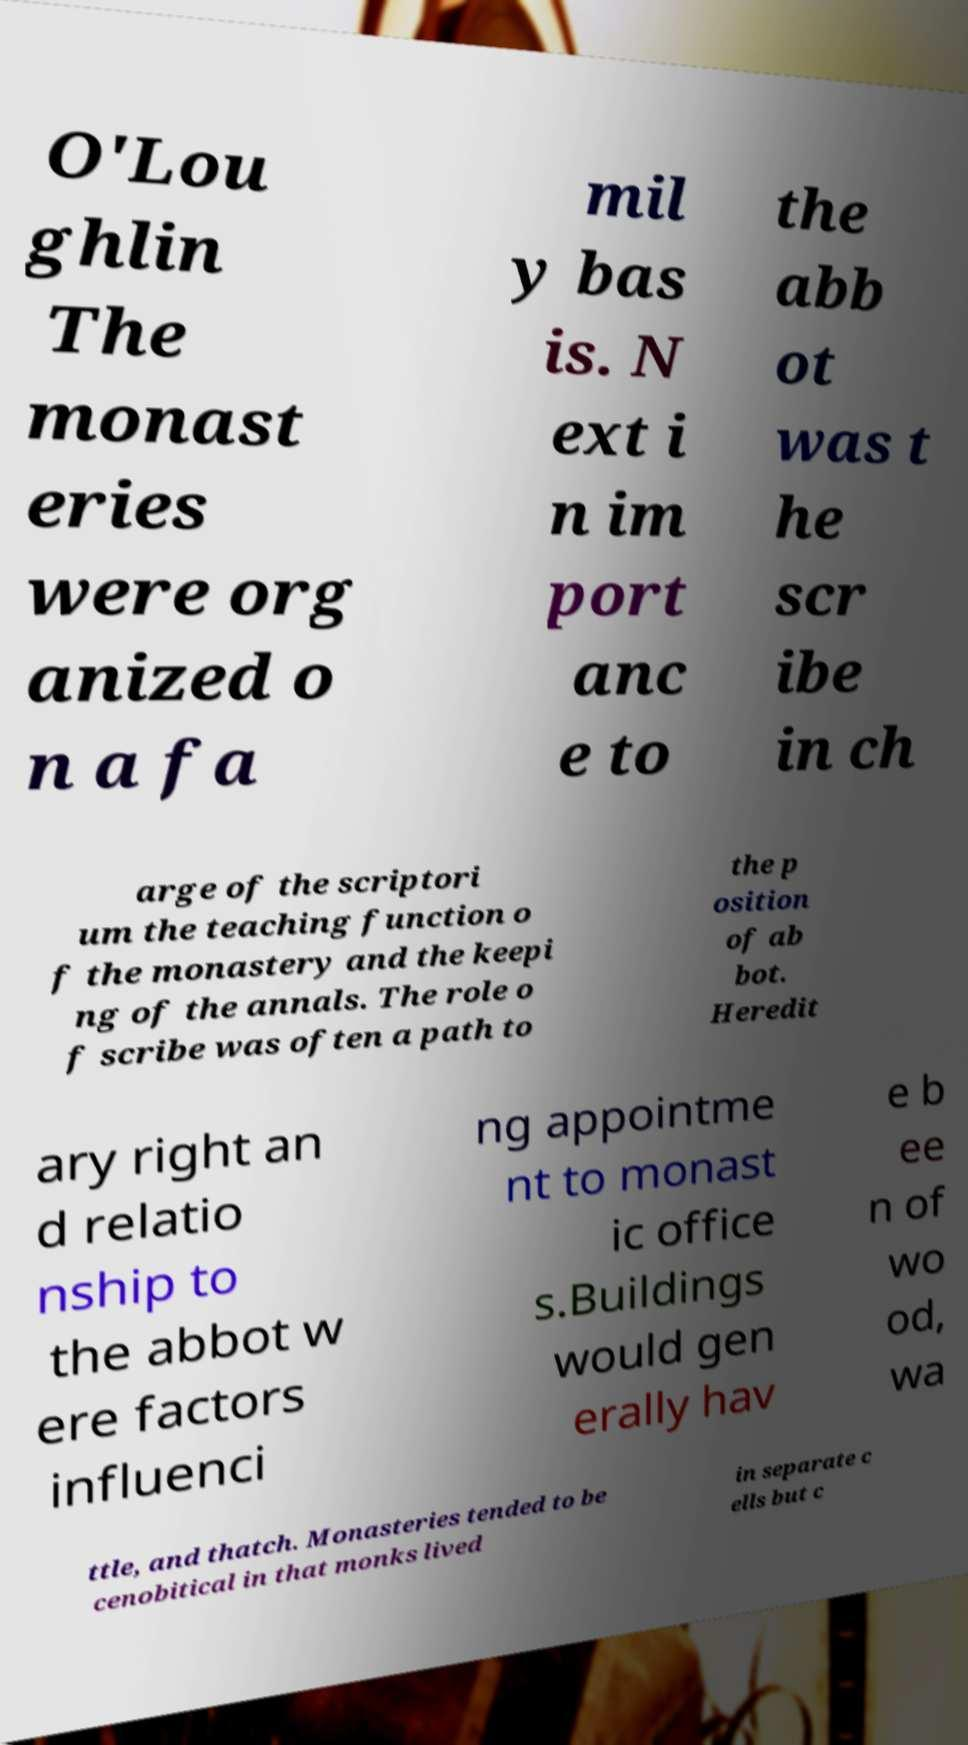For documentation purposes, I need the text within this image transcribed. Could you provide that? O'Lou ghlin The monast eries were org anized o n a fa mil y bas is. N ext i n im port anc e to the abb ot was t he scr ibe in ch arge of the scriptori um the teaching function o f the monastery and the keepi ng of the annals. The role o f scribe was often a path to the p osition of ab bot. Heredit ary right an d relatio nship to the abbot w ere factors influenci ng appointme nt to monast ic office s.Buildings would gen erally hav e b ee n of wo od, wa ttle, and thatch. Monasteries tended to be cenobitical in that monks lived in separate c ells but c 